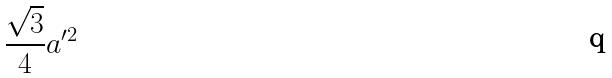<formula> <loc_0><loc_0><loc_500><loc_500>\frac { \sqrt { 3 } } { 4 } a ^ { \prime 2 }</formula> 